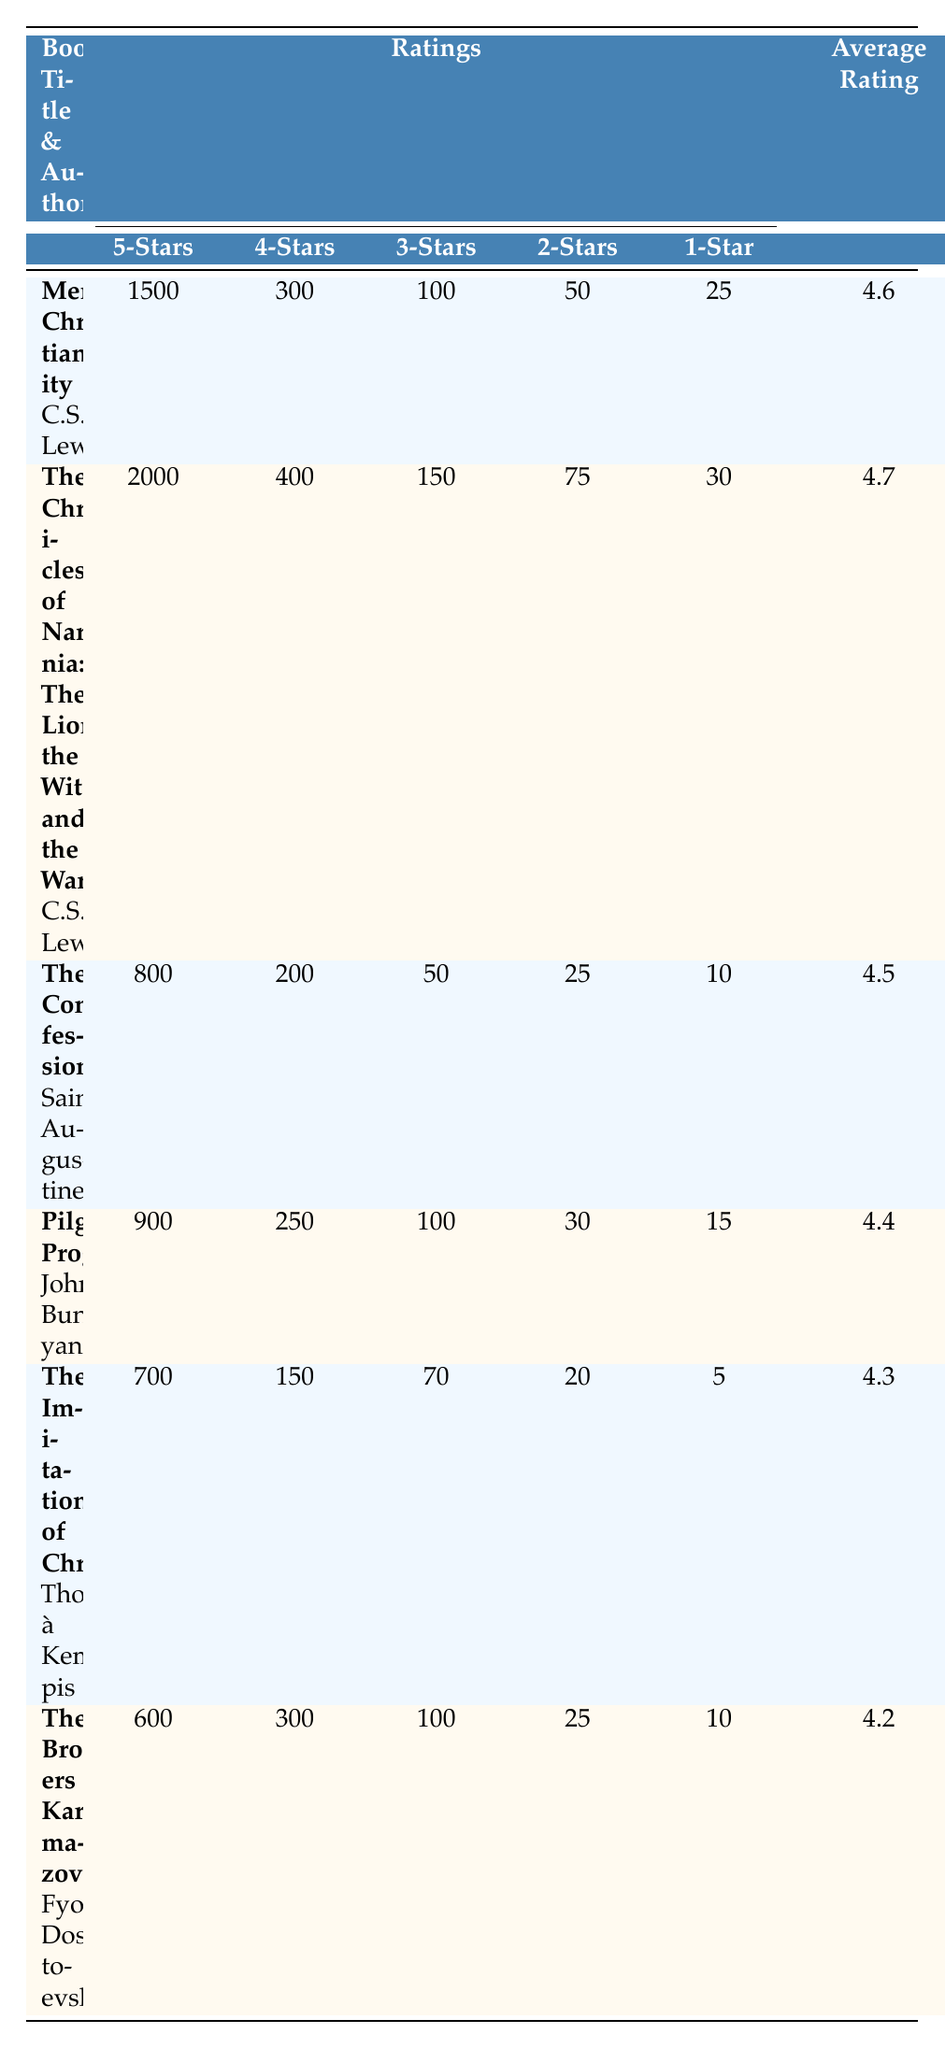What is the highest average rating among the listed books? The average ratings for the books are: "Mere Christianity" - 4.6, "The Chronicles of Narnia" - 4.7, "The Confessions" - 4.5, "Pilgrim's Progress" - 4.4, "The Imitation of Christ" - 4.3, and "The Brothers Karamazov" - 4.2. The highest average rating is 4.7 for "The Chronicles of Narnia".
Answer: 4.7 How many books received a rating of 5 stars from over 1000 readers? The books with 5-star ratings over 1000 are: "Mere Christianity" (1500) and "The Chronicles of Narnia" (2000). Thus, there are two books.
Answer: 2 Is there a book by C.S. Lewis that has a higher average rating than "The Imitation of Christ"? "The Imitation of Christ" has an average rating of 4.3. The two books by C.S. Lewis are "Mere Christianity" (4.6) and "The Chronicles of Narnia" (4.7), both of which have higher ratings. Thus, yes, there are two books.
Answer: Yes What is the total number of 1-star ratings across all the books? The 1-star ratings for the books are: "Mere Christianity" - 25, "The Chronicles of Narnia" - 30, "The Confessions" - 10, "Pilgrim's Progress" - 15, "The Imitation of Christ" - 5, and "The Brothers Karamazov" - 10. Summing them gives 25 + 30 + 10 + 15 + 5 + 10 = 95.
Answer: 95 Which author has the highest total number of ratings? Total ratings for each author are calculated as follows: C.S. Lewis - (1500 + 300 + 2000 + 400) = 3200, Saint Augustine - (800 + 200) = 1000, John Bunyan - (900 + 250) = 1150, Thomas à Kempis - (700 + 150) = 850, Fyodor Dostoevsky - (600 + 300) = 900. C.S. Lewis has the highest total ratings of 3200.
Answer: C.S. Lewis 